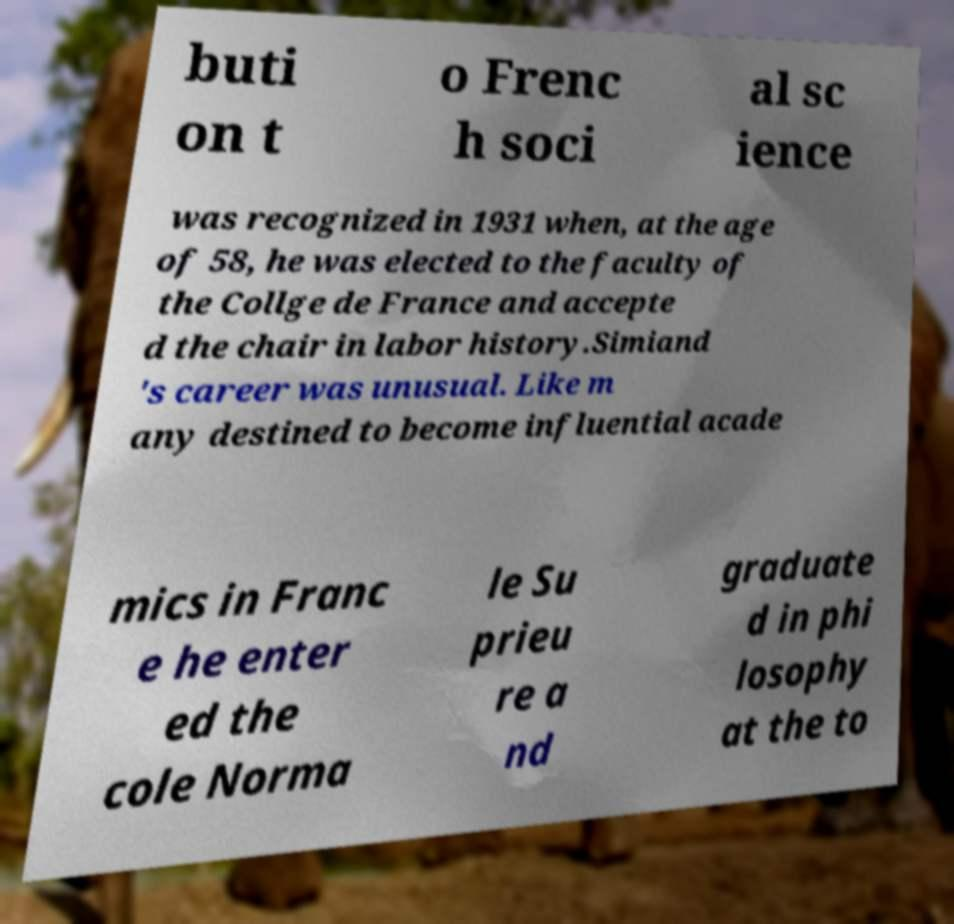I need the written content from this picture converted into text. Can you do that? buti on t o Frenc h soci al sc ience was recognized in 1931 when, at the age of 58, he was elected to the faculty of the Collge de France and accepte d the chair in labor history.Simiand 's career was unusual. Like m any destined to become influential acade mics in Franc e he enter ed the cole Norma le Su prieu re a nd graduate d in phi losophy at the to 